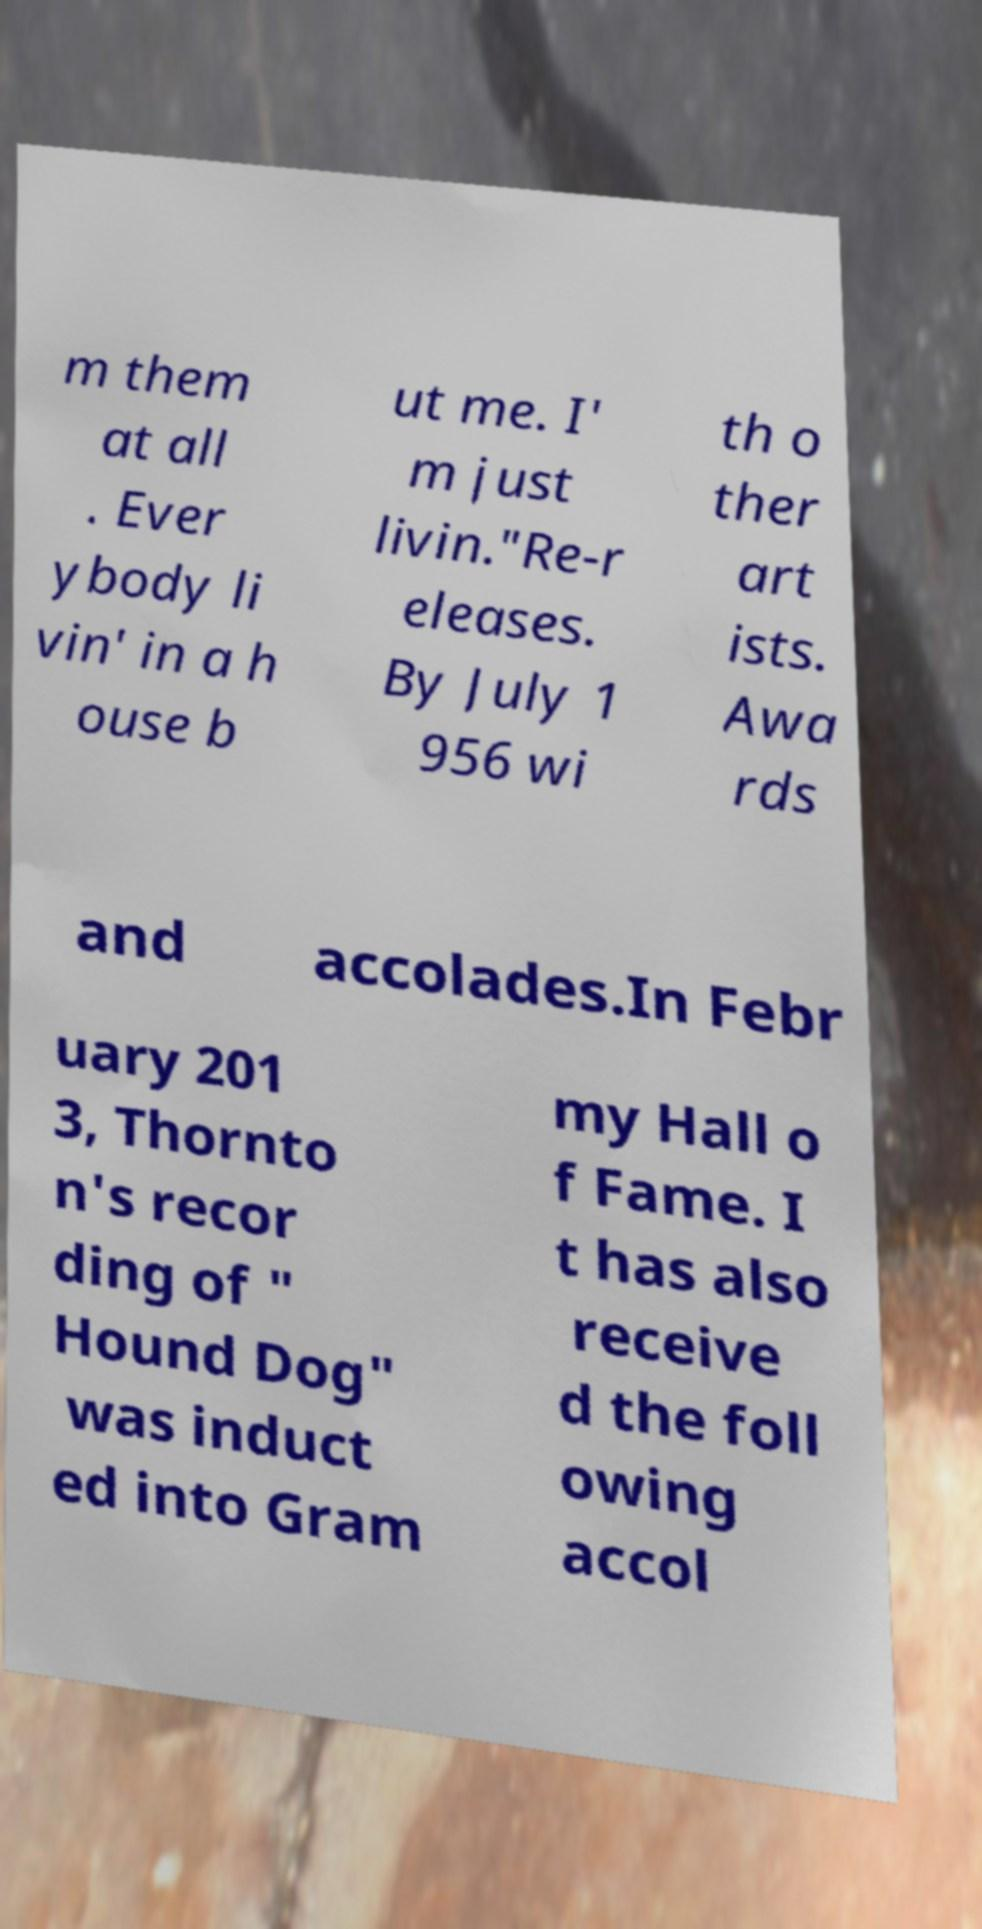Can you read and provide the text displayed in the image?This photo seems to have some interesting text. Can you extract and type it out for me? m them at all . Ever ybody li vin' in a h ouse b ut me. I' m just livin."Re-r eleases. By July 1 956 wi th o ther art ists. Awa rds and accolades.In Febr uary 201 3, Thornto n's recor ding of " Hound Dog" was induct ed into Gram my Hall o f Fame. I t has also receive d the foll owing accol 